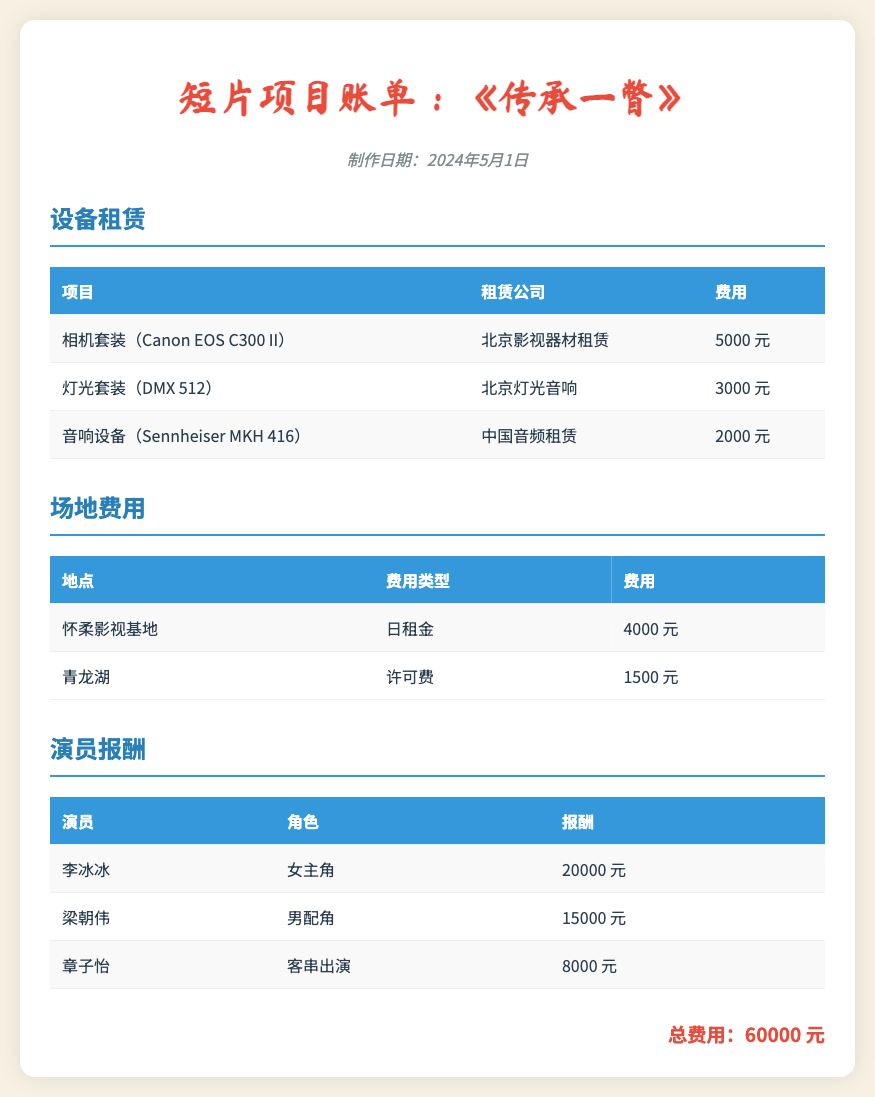什么是制作日期？ 制作日期显示在文档的标题下方，表明账单的生成时间。
Answer: 2024年5月1日 相机套装的租赁公司是什么？ 相机套装的租赁公司列在设备租赁部分的相应行中。
Answer: 北京影视器材租赁 演员李冰冰的报酬是多少？ 李冰冰的报酬在演员报酬部分中具体列出。
Answer: 20000 元 所有设备租赁的总费用是多少？ 通过查看设备租赁部分的每一项费用相加，可以得到总费用。
Answer: 10000 元 怀柔影视基地的日租金是多少？ 日租金的金额在场地费用部分显而易见。
Answer: 4000 元 总费用是多少？ 总费用是文档底部总结的一项信息，显示所有费用的总和。
Answer: 60000 元 章子怡在影片中的角色是什么？ 角色的名称在演员报酬部分列出。
Answer: 客串出演 青龙湖的许可费是多少？ 许可费的金额在场地费用部分明确列出。
Answer: 1500 元 灯光套装的租赁金额是多少？ 灯光套装的费用在设备租赁部分中注明。
Answer: 3000 元 